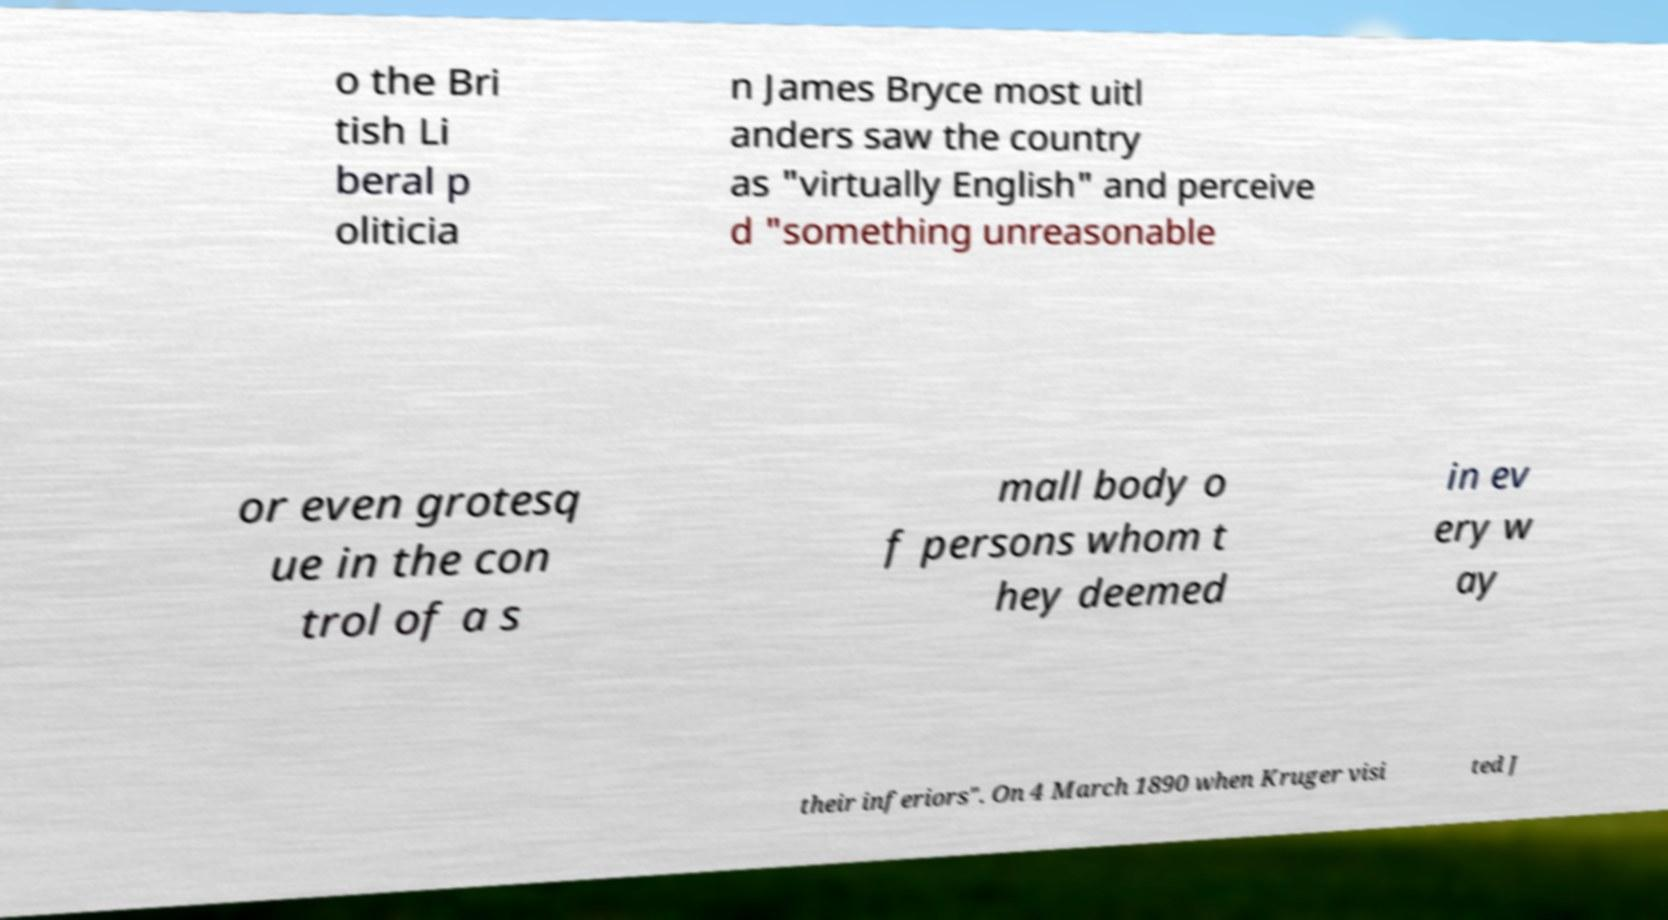Please identify and transcribe the text found in this image. o the Bri tish Li beral p oliticia n James Bryce most uitl anders saw the country as "virtually English" and perceive d "something unreasonable or even grotesq ue in the con trol of a s mall body o f persons whom t hey deemed in ev ery w ay their inferiors". On 4 March 1890 when Kruger visi ted J 